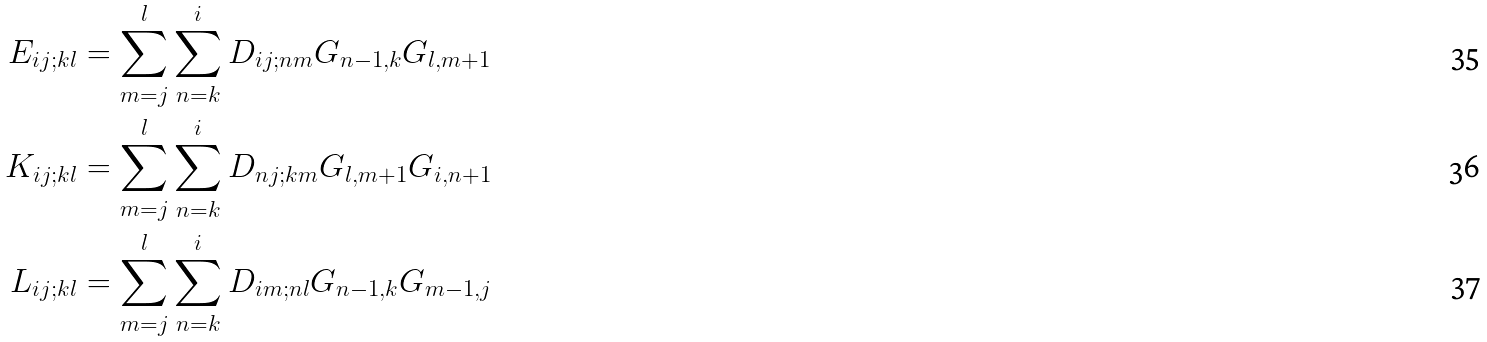<formula> <loc_0><loc_0><loc_500><loc_500>E _ { i j ; k l } & = \sum _ { m = j } ^ { l } \sum _ { n = k } ^ { i } D _ { i j ; n m } G _ { n - 1 , k } G _ { l , m + 1 } \\ K _ { i j ; k l } & = \sum _ { m = j } ^ { l } \sum _ { n = k } ^ { i } D _ { n j ; k m } G _ { l , m + 1 } G _ { i , n + 1 } \\ L _ { i j ; k l } & = \sum _ { m = j } ^ { l } \sum _ { n = k } ^ { i } D _ { i m ; n l } G _ { n - 1 , k } G _ { m - 1 , j }</formula> 